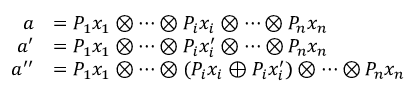<formula> <loc_0><loc_0><loc_500><loc_500>\begin{array} { r l } { a } & { = P _ { 1 } x _ { 1 } \otimes \cdots \otimes P _ { i } x _ { i } \otimes \cdots \otimes P _ { n } x _ { n } } \\ { a ^ { \prime } } & { = P _ { 1 } x _ { 1 } \otimes \cdots \otimes P _ { i } x _ { i } ^ { \prime } \otimes \cdots \otimes P _ { n } x _ { n } } \\ { a ^ { \prime \prime } } & { = P _ { 1 } x _ { 1 } \otimes \cdots \otimes ( P _ { i } x _ { i } \oplus P _ { i } x _ { i } ^ { \prime } ) \otimes \cdots \otimes P _ { n } x _ { n } } \end{array}</formula> 